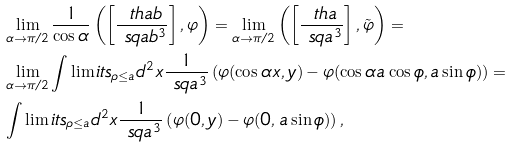<formula> <loc_0><loc_0><loc_500><loc_500>& \lim _ { \alpha \to \pi / 2 } \frac { 1 } { \cos \alpha } \left ( \left [ \frac { \ t h a b } { \ s q a b ^ { 3 } } \right ] , \varphi \right ) = \lim _ { \alpha \to \pi / 2 } \left ( \left [ \frac { \ t h a } { \ s q a ^ { 3 } } \right ] , \tilde { \varphi } \right ) = \\ & \lim _ { \alpha \to \pi / 2 } \int \lim i t s _ { \rho \leq a } d ^ { 2 } x \frac { 1 } { \ s q a ^ { 3 } } \left ( \varphi ( \cos \alpha x , y ) - \varphi ( \cos \alpha a \cos \phi , a \sin \phi ) \right ) = \\ & \int \lim i t s _ { \rho \leq a } d ^ { 2 } x \frac { 1 } { \ s q a ^ { 3 } } \left ( \varphi ( 0 , y ) - \varphi ( 0 , a \sin \phi ) \right ) ,</formula> 